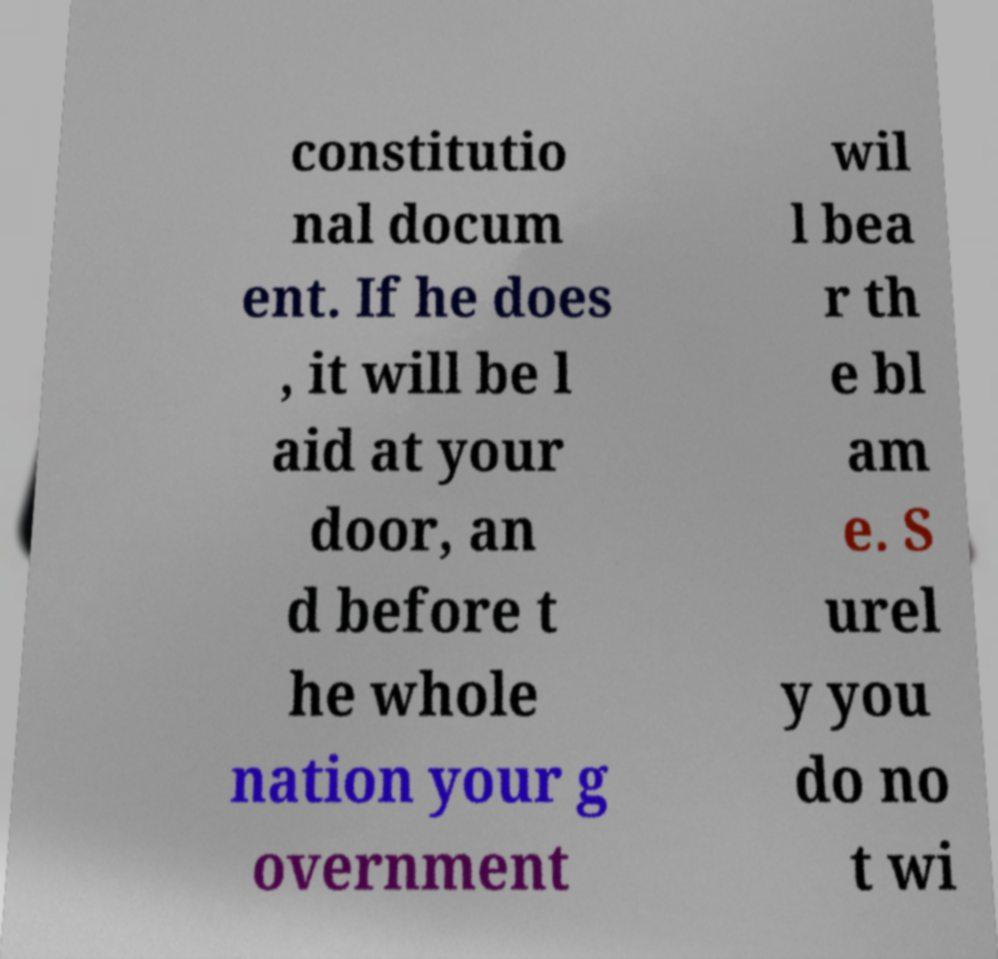I need the written content from this picture converted into text. Can you do that? constitutio nal docum ent. If he does , it will be l aid at your door, an d before t he whole nation your g overnment wil l bea r th e bl am e. S urel y you do no t wi 